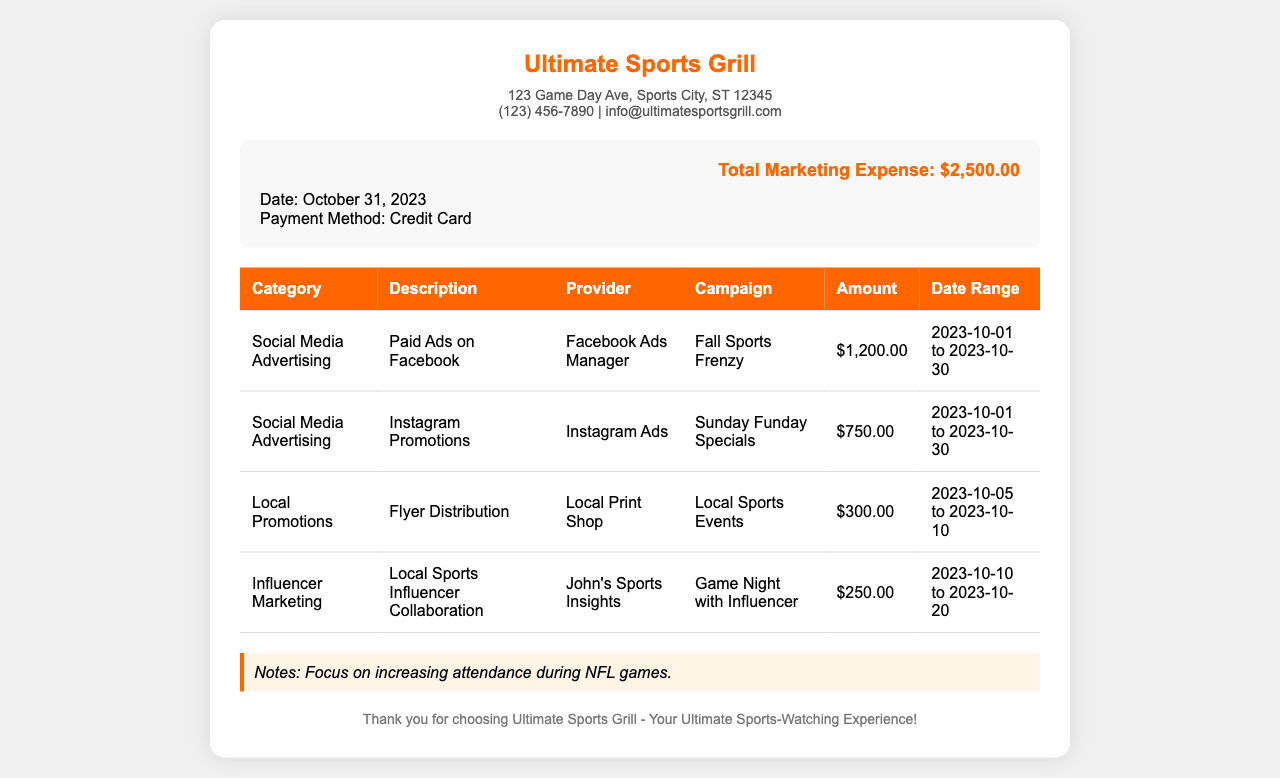What is the total marketing expense? The total marketing expense is clearly stated in the summary section of the receipt.
Answer: $2,500.00 What is the payment method? The payment method used for the marketing expenses is listed in the summary section.
Answer: Credit Card Which social media platform had the highest advertising cost? The costs of advertising on different platforms are compared in the table; Facebook has the highest amount.
Answer: Facebook Ads Manager What is the date range for the flyer distribution? The date range for the flyer distribution service is specified in the marketing expense table.
Answer: 2023-10-05 to 2023-10-10 How much was spent on Instagram promotions? The amount spent on Instagram promotions is listed under the corresponding entry in the table.
Answer: $750.00 What type of marketing involved local influencer collaboration? The type of marketing related to the local influencer collaboration can be found in the category column of the table.
Answer: Influencer Marketing Which campaign is associated with the highest expenditure? The campaigns can be compared based on their amounts in the table; “Fall Sports Frenzy” has the highest expenditure.
Answer: Fall Sports Frenzy What is noted as a focus for the next marketing campaigns? The focus for future marketing efforts is highlighted in the notes section at the bottom of the receipt.
Answer: Increasing attendance during NFL games 